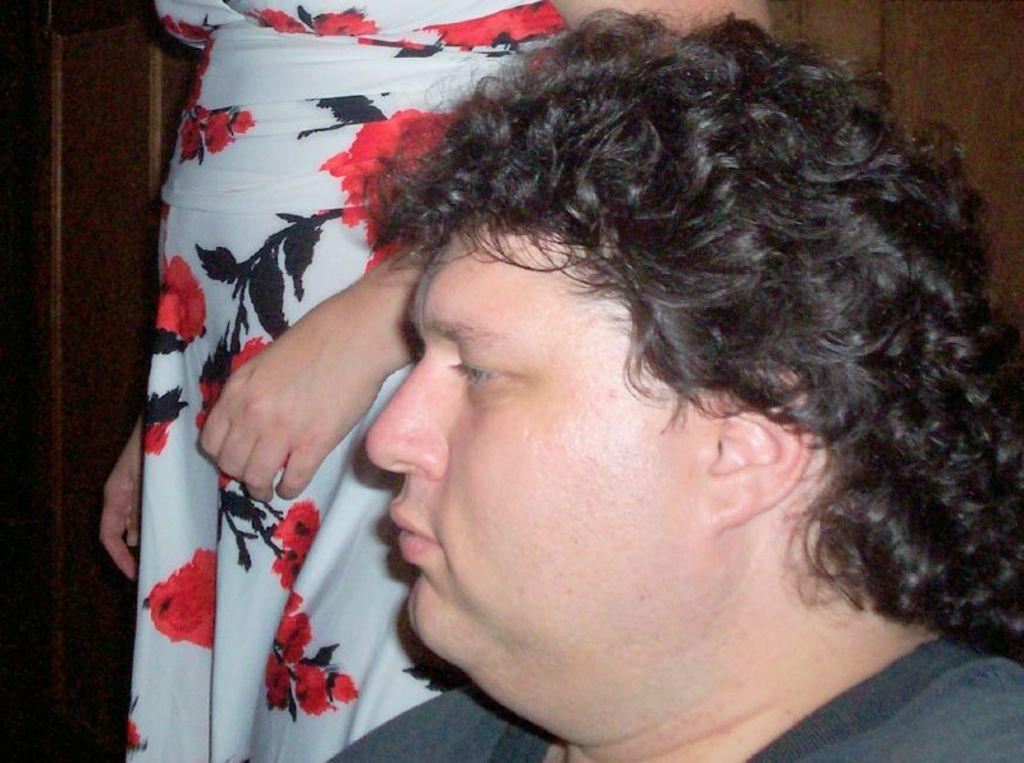Who is the main subject in the image? There is a man in the image. Can you describe the other person in the image? There is another person standing behind the man. What type of structure can be seen in the background of the image? There is a wooden wall in the background of the image. What color is the sweater worn by the person in the downtown area during the earthquake? There is no sweater, downtown area, or earthquake mentioned in the image. The image only features a man and another person standing in front of a wooden wall. 